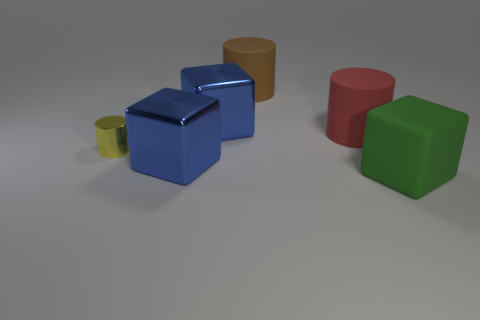There is a shiny thing that is behind the small yellow shiny cylinder; does it have the same shape as the large blue object in front of the small shiny cylinder?
Make the answer very short. Yes. What is the material of the big thing in front of the blue metal cube in front of the cylinder on the left side of the big brown rubber cylinder?
Give a very brief answer. Rubber. What shape is the brown rubber object that is the same size as the red matte thing?
Your answer should be compact. Cylinder. Are there any metallic blocks of the same color as the small shiny cylinder?
Provide a short and direct response. No. The brown rubber cylinder is what size?
Provide a succinct answer. Large. Is the material of the yellow thing the same as the green object?
Give a very brief answer. No. How many blue shiny things are on the right side of the big brown matte cylinder behind the red object on the right side of the large brown rubber cylinder?
Your answer should be very brief. 0. The big metallic object behind the small cylinder has what shape?
Ensure brevity in your answer.  Cube. What number of other things are there of the same material as the red cylinder
Ensure brevity in your answer.  2. Does the matte block have the same color as the tiny object?
Ensure brevity in your answer.  No. 